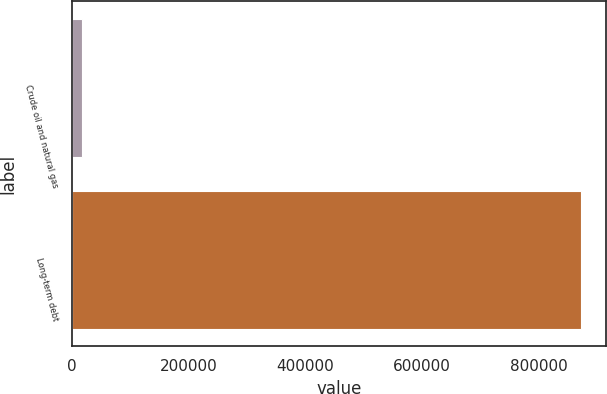Convert chart. <chart><loc_0><loc_0><loc_500><loc_500><bar_chart><fcel>Crude oil and natural gas<fcel>Long-term debt<nl><fcel>16032<fcel>871540<nl></chart> 